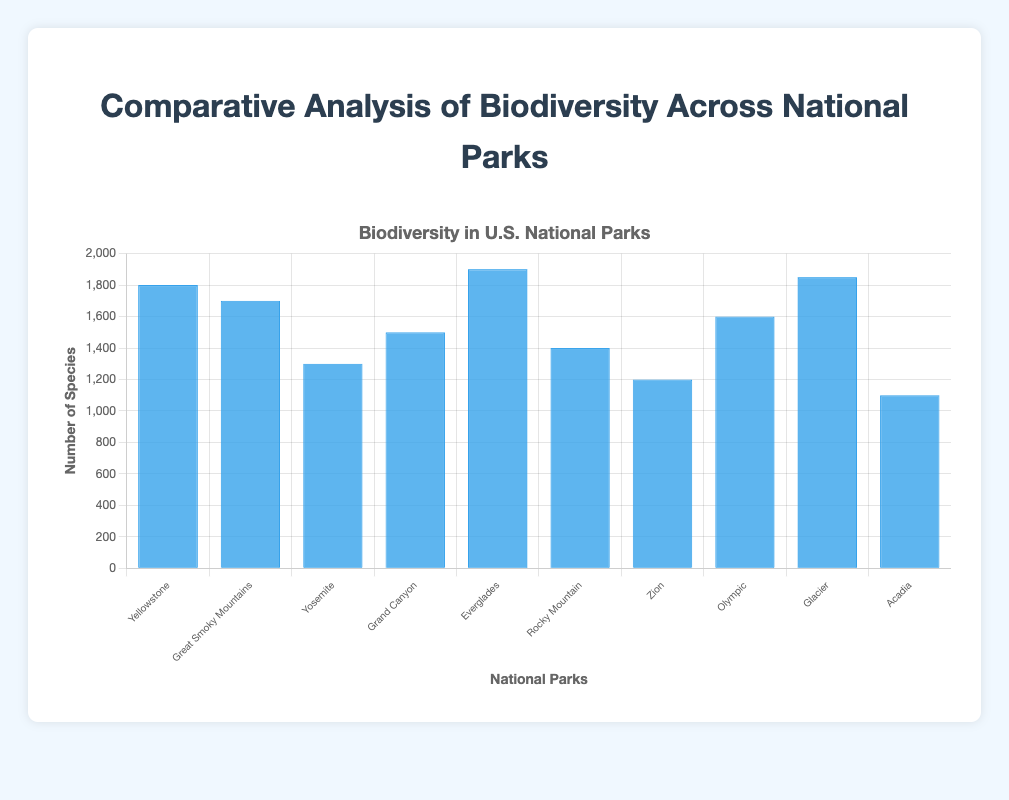What is the national park with the highest number of species? The visually tallest blue bar represents the national park with the highest number of species. According to the chart, Everglades National Park has the longest bar, indicating it has the highest biodiversity.
Answer: Everglades National Park Which national park has 1,500 species? By examining the bar heights and their corresponding labels, the bar representing Grand Canyon National Park reaches the 1,500 species mark.
Answer: Grand Canyon National Park What is the combined number of species in Yellowstone and Olympic National Parks? First, find the heights of the bars for both parks. Yellowstone has 1,800 species, and Olympic has 1,600 species. Adding them together gives 1,800 + 1,600.
Answer: 3,400 Which national park has fewer species, Zion or Acadia? Compare the height of the bars for Zion and Acadia. Zion's bar reaches 1,200 species, whereas Acadia's bar reaches 1,100 species. Thus, Acadia has fewer species.
Answer: Acadia National Park What is the difference in the number of species between Glacier and Yosemite National Parks? Determine the heights of the bars for both parks. Glacier has 1,850 species, and Yosemite has 1,300 species. Subtracting these gives 1,850 - 1,300.
Answer: 550 Rank the top three national parks with the highest biodiversity. Identify the three tallest bars. Everglades (1,900 species), Glacier (1,850 species), and Yellowstone (1,800 species) have the highest biodiversity.
Answer: Everglades, Glacier, Yellowstone What is the average number of species across all listed national parks? Sum the number of species of all parks and divide by the number of parks (10). (1,800 + 1,700 + 1,300 + 1,500 + 1,900 + 1,400 + 1,200 + 1,600 + 1,850 + 1,100) / 10 = 16,350 / 10.
Answer: 1,635 Which national park shows a biodiversity between 1,700 and 1,800 species? Locate the bars with heights between these values. The bar for Great Smoky Mountains National Park fits this range with 1,700 species.
Answer: Great Smoky Mountains National Park Which two national parks together have a total of 2,600 species? Identify pairs of bars whose combined heights equal 2,600. Rocky Mountain (1,400) and Zion National Park (1,200) together sum to 1,400 + 1,200.
Answer: Rocky Mountain and Zion National Park 